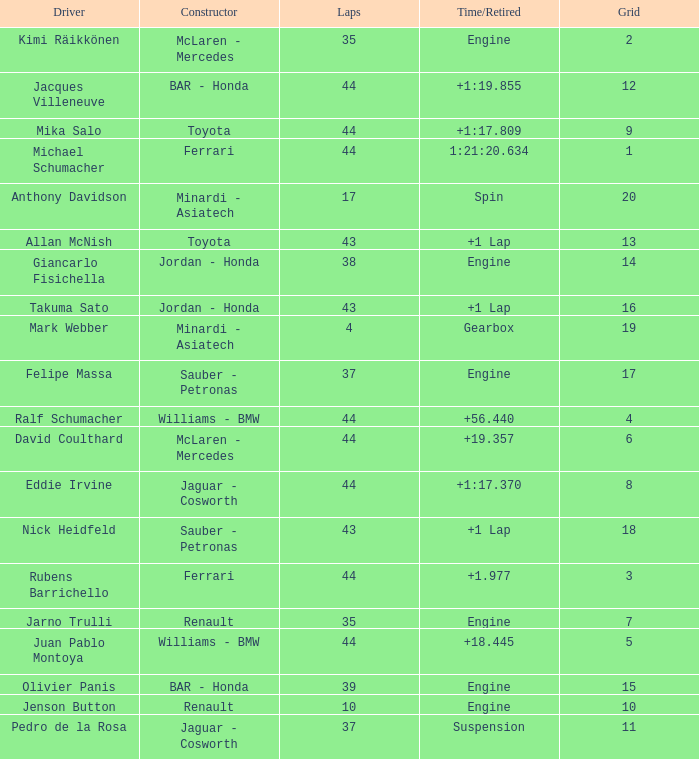What was the time of the driver on grid 3? 1.977. 